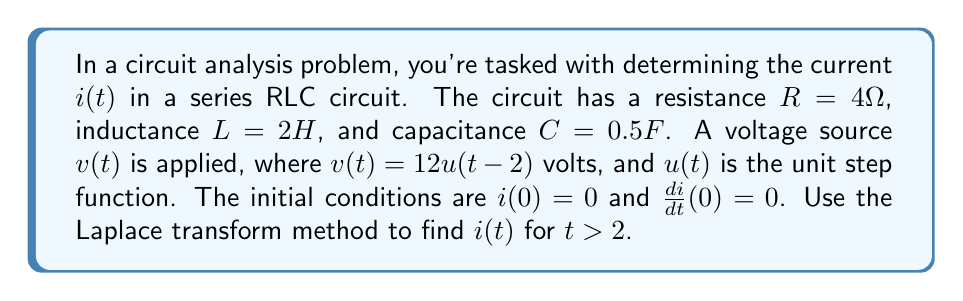Give your solution to this math problem. Let's solve this step-by-step using the Laplace transform method:

1) First, we need to write the differential equation for the circuit:

   $$L\frac{d^2i}{dt^2} + R\frac{di}{dt} + \frac{1}{C}i = \frac{dv}{dt}$$

2) Substituting the given values:

   $$2\frac{d^2i}{dt^2} + 4\frac{di}{dt} + 2i = \frac{dv}{dt}$$

3) Now, let's take the Laplace transform of both sides. Let $I(s)$ be the Laplace transform of $i(t)$:

   $$2[s^2I(s) - si(0) - i'(0)] + 4[sI(s) - i(0)] + 2I(s) = s[V(s)]$$

4) The Laplace transform of $v(t) = 12u(t-2)$ is:

   $$V(s) = \frac{12e^{-2s}}{s}$$

5) Substituting the initial conditions and $V(s)$:

   $$2s^2I(s) + 4sI(s) + 2I(s) = 12se^{-2s}$$

6) Factoring out $I(s)$:

   $$I(s)(2s^2 + 4s + 2) = 12se^{-2s}$$

7) Solving for $I(s)$:

   $$I(s) = \frac{12se^{-2s}}{2s^2 + 4s + 2} = \frac{6se^{-2s}}{s^2 + 2s + 1}$$

8) To find the inverse Laplace transform, we can use partial fraction decomposition:

   $$\frac{6se^{-2s}}{s^2 + 2s + 1} = 6e^{-2s}(\frac{s+1}{(s+1)^2} - \frac{1}{(s+1)^2})$$

9) The inverse Laplace transform of this expression is:

   $$i(t) = 6e^{-2s}[te^{-t} - e^{-t}]u(t-2)$$

10) Simplifying:

    $$i(t) = 6(t-2)e^{-(t-2)}u(t-2)$$

This is the final expression for $i(t)$ for $t > 2$.
Answer: $i(t) = 6(t-2)e^{-(t-2)}u(t-2)$ for $t > 2$ 